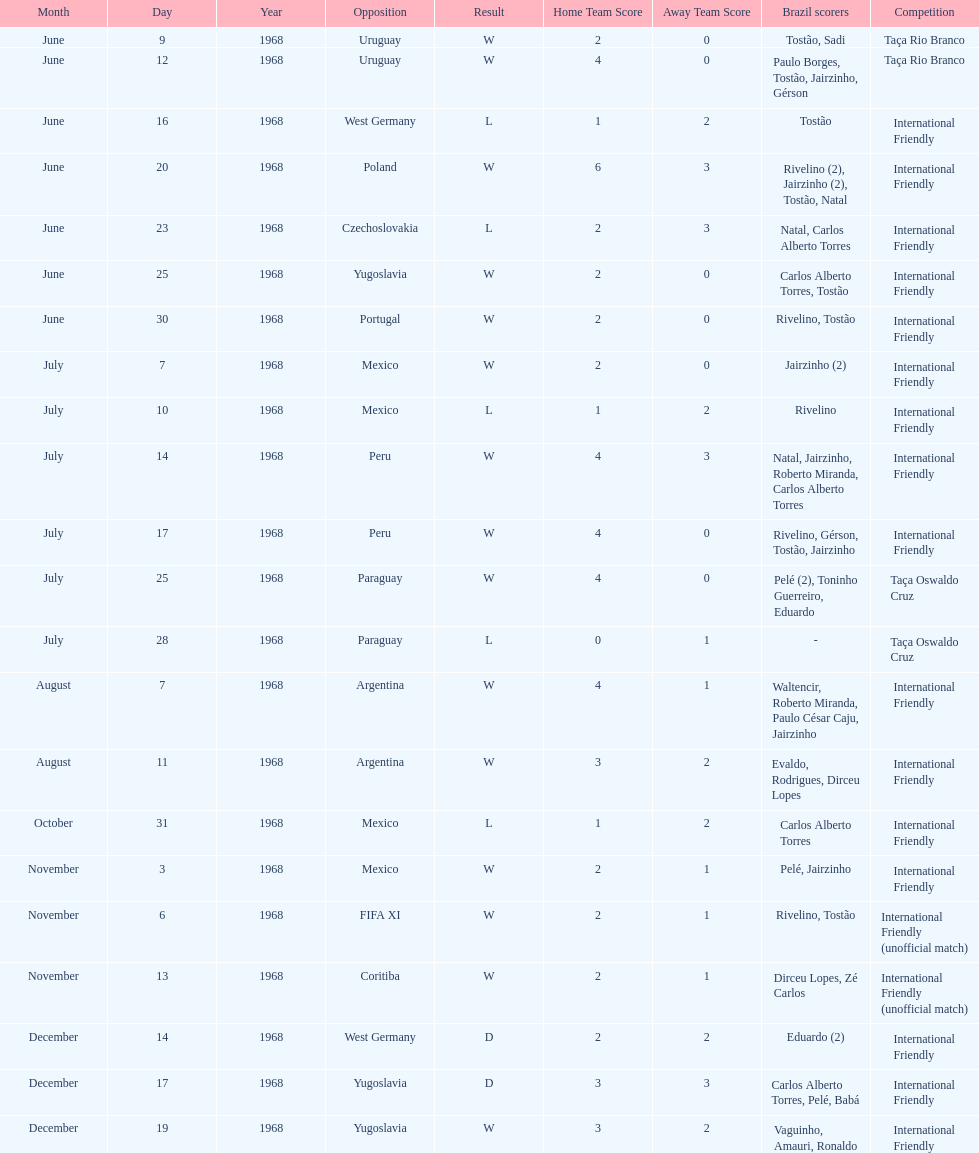The most goals scored by brazil in a game 6. 